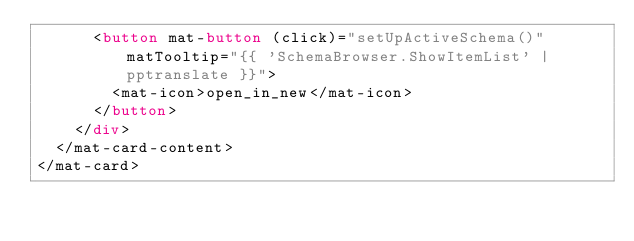<code> <loc_0><loc_0><loc_500><loc_500><_HTML_>      <button mat-button (click)="setUpActiveSchema()" matTooltip="{{ 'SchemaBrowser.ShowItemList' | pptranslate }}">
        <mat-icon>open_in_new</mat-icon>
      </button>
    </div>
  </mat-card-content>
</mat-card></code> 